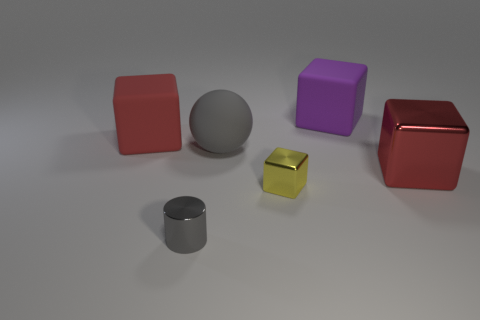Considering the positions of the objects, can they be part of a pattern or sequence? Yes, the objects can be seen as following a descending size order from left to right. The arrangement starts with the largest cube and ends with the smallest cylinder, creating a visually appealing sequence by size. 